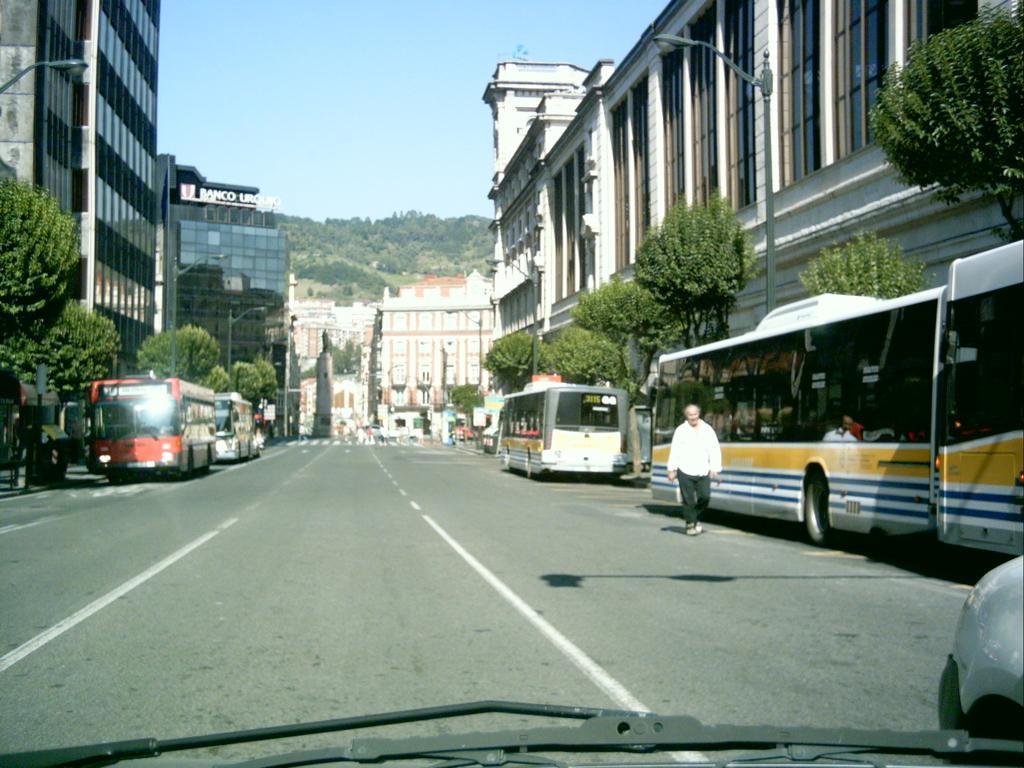Could you give a brief overview of what you see in this image? This image is taken on a road where there are buses parked on the road and on the left side there are buildings, trees. In the background there are buildings, trees. On the right side there are trees, pole, buildings, and there is a man walking on the road. 